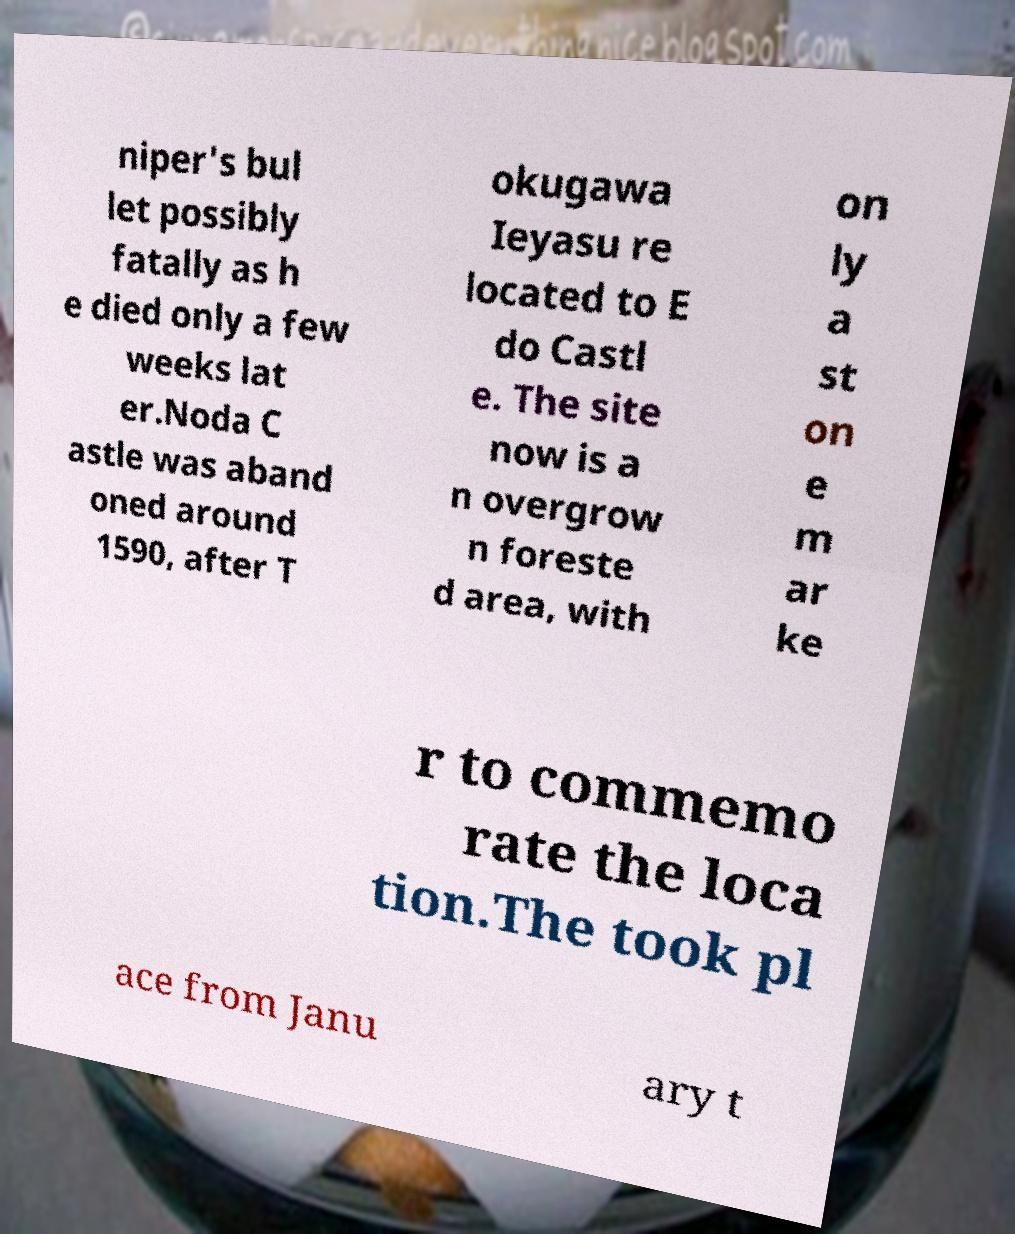I need the written content from this picture converted into text. Can you do that? niper's bul let possibly fatally as h e died only a few weeks lat er.Noda C astle was aband oned around 1590, after T okugawa Ieyasu re located to E do Castl e. The site now is a n overgrow n foreste d area, with on ly a st on e m ar ke r to commemo rate the loca tion.The took pl ace from Janu ary t 